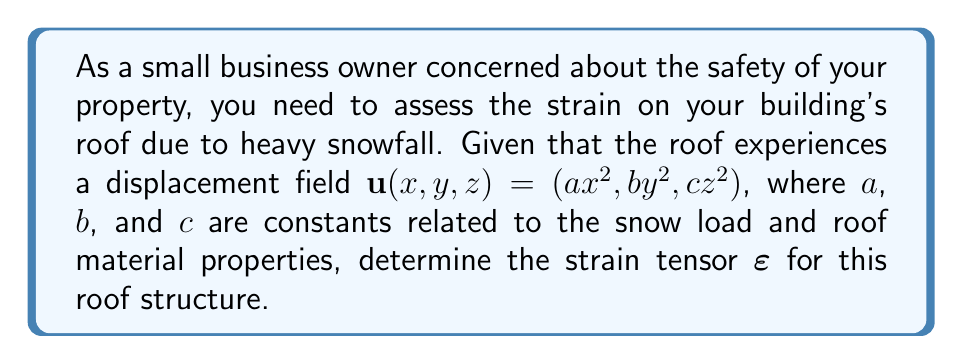Can you solve this math problem? To determine the strain tensor for the roof structure, we'll follow these steps:

1) The strain tensor $\boldsymbol{\varepsilon}$ is defined as:

   $$\boldsymbol{\varepsilon} = \frac{1}{2}(\nabla \mathbf{u} + (\nabla \mathbf{u})^T)$$

   where $\nabla \mathbf{u}$ is the gradient of the displacement field.

2) First, let's calculate $\nabla \mathbf{u}$:

   $$\nabla \mathbf{u} = \begin{bmatrix}
   \frac{\partial u_x}{\partial x} & \frac{\partial u_x}{\partial y} & \frac{\partial u_x}{\partial z} \\
   \frac{\partial u_y}{\partial x} & \frac{\partial u_y}{\partial y} & \frac{\partial u_y}{\partial z} \\
   \frac{\partial u_z}{\partial x} & \frac{\partial u_z}{\partial y} & \frac{\partial u_z}{\partial z}
   \end{bmatrix} = \begin{bmatrix}
   2ax & 0 & 0 \\
   0 & 2by & 0 \\
   0 & 0 & 2cz
   \end{bmatrix}$$

3) Now, let's calculate $(\nabla \mathbf{u})^T$:

   $$(\nabla \mathbf{u})^T = \begin{bmatrix}
   2ax & 0 & 0 \\
   0 & 2by & 0 \\
   0 & 0 & 2cz
   \end{bmatrix}$$

4) Adding $\nabla \mathbf{u}$ and $(\nabla \mathbf{u})^T$:

   $$\nabla \mathbf{u} + (\nabla \mathbf{u})^T = \begin{bmatrix}
   4ax & 0 & 0 \\
   0 & 4by & 0 \\
   0 & 0 & 4cz
   \end{bmatrix}$$

5) Finally, multiplying by $\frac{1}{2}$ to get the strain tensor:

   $$\boldsymbol{\varepsilon} = \frac{1}{2}(\nabla \mathbf{u} + (\nabla \mathbf{u})^T) = \begin{bmatrix}
   2ax & 0 & 0 \\
   0 & 2by & 0 \\
   0 & 0 & 2cz
   \end{bmatrix}$$

This strain tensor describes how the roof structure deforms under the heavy snow load.
Answer: $$\boldsymbol{\varepsilon} = \begin{bmatrix}
2ax & 0 & 0 \\
0 & 2by & 0 \\
0 & 0 & 2cz
\end{bmatrix}$$ 